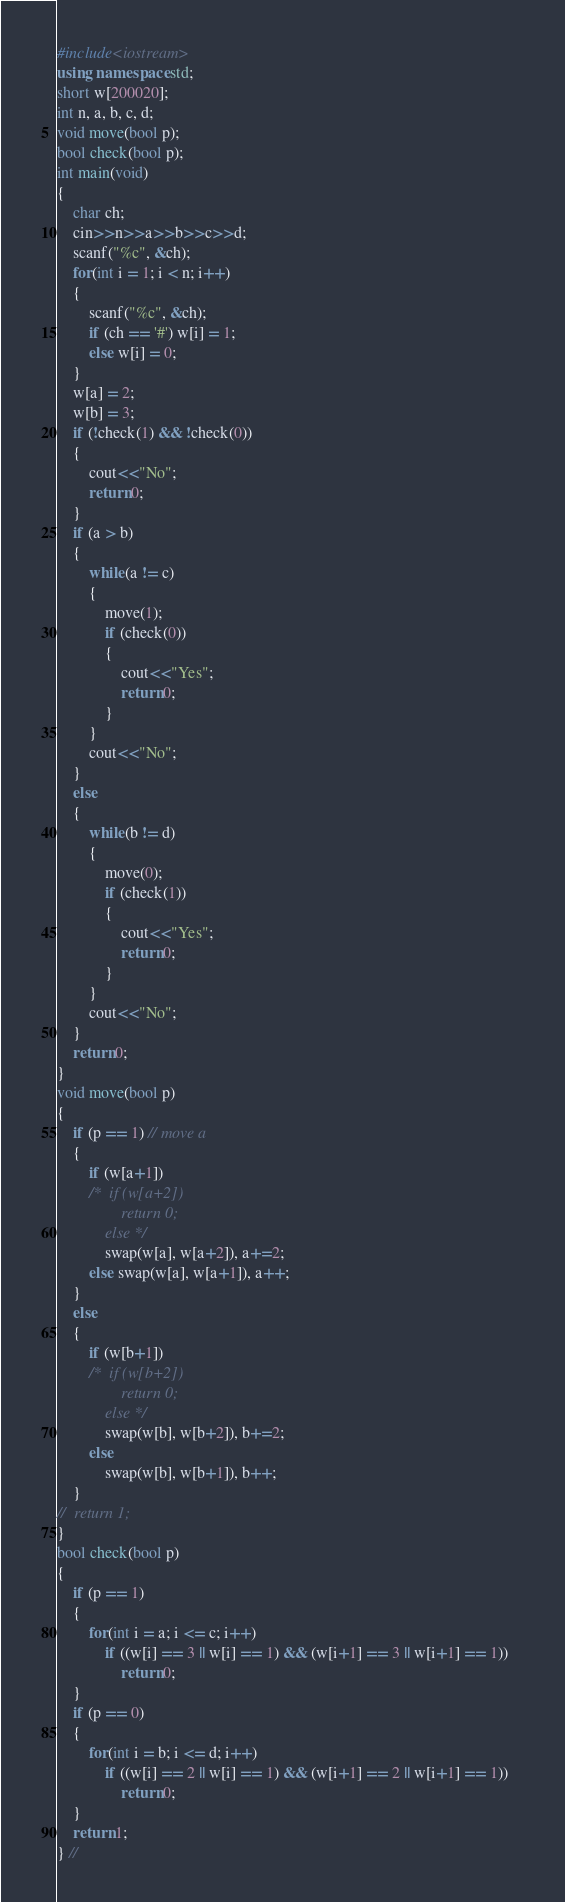<code> <loc_0><loc_0><loc_500><loc_500><_C++_>#include<iostream>
using namespace std;
short w[200020];
int n, a, b, c, d;
void move(bool p);
bool check(bool p);
int main(void)
{
	char ch;
	cin>>n>>a>>b>>c>>d;
	scanf("%c", &ch);
	for(int i = 1; i < n; i++)
	{
		scanf("%c", &ch);
		if (ch == '#') w[i] = 1;
		else w[i] = 0;
	}
	w[a] = 2;
	w[b] = 3;
	if (!check(1) && !check(0))
	{
		cout<<"No";
		return 0;
	}
	if (a > b)
	{
		while(a != c)
		{
			move(1);
			if (check(0))
			{
				cout<<"Yes";
				return 0;
			}	
		}
		cout<<"No";
	}	
	else
	{
		while(b != d)
		{
			move(0);
			if (check(1))
			{
				cout<<"Yes";
				return 0;
			}
		}
		cout<<"No";
	}
	return 0;
}
void move(bool p)
{
	if (p == 1) // move a
	{
		if (w[a+1])
		/*	if (w[a+2])
				return 0;
			else */
			swap(w[a], w[a+2]), a+=2;
		else swap(w[a], w[a+1]), a++; 
	}
	else
	{
		if (w[b+1])
		/*	if (w[b+2])
				return 0;
			else */
			swap(w[b], w[b+2]), b+=2;		
		else
			swap(w[b], w[b+1]), b++;
	}
//	return 1;
}
bool check(bool p)
{
	if (p == 1)
	{
		for(int i = a; i <= c; i++)
			if ((w[i] == 3 || w[i] == 1) && (w[i+1] == 3 || w[i+1] == 1))
				return 0;
	}		
	if (p == 0)
	{
		for(int i = b; i <= d; i++)
			if ((w[i] == 2 || w[i] == 1) && (w[i+1] == 2 || w[i+1] == 1))	
				return 0;
	}					
	return 1;
} //</code> 